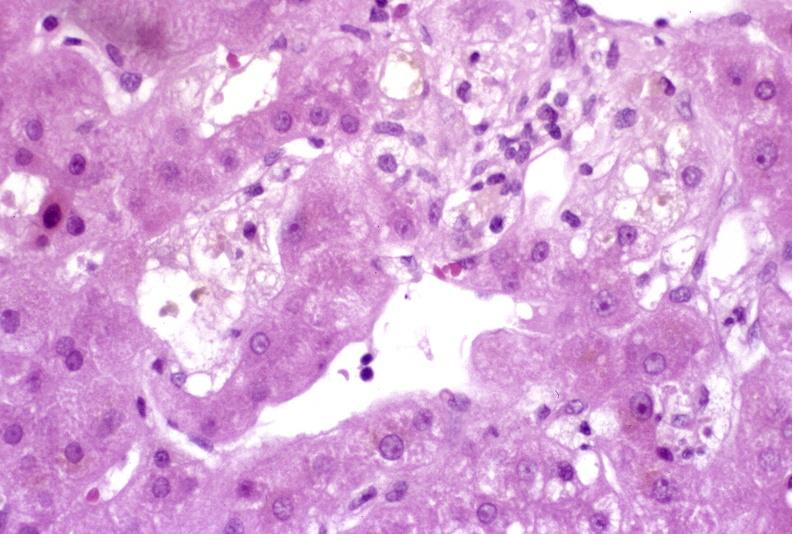what is present?
Answer the question using a single word or phrase. Hepatobiliary 